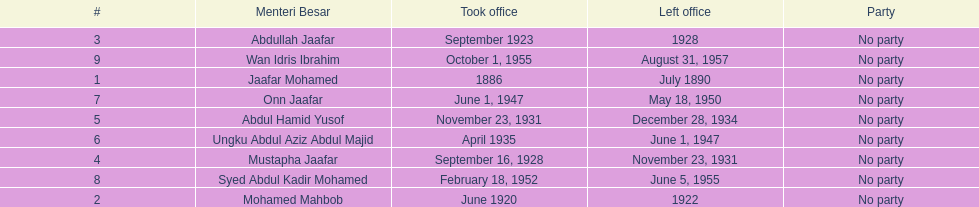Name someone who was not in office more than 4 years. Mohamed Mahbob. 